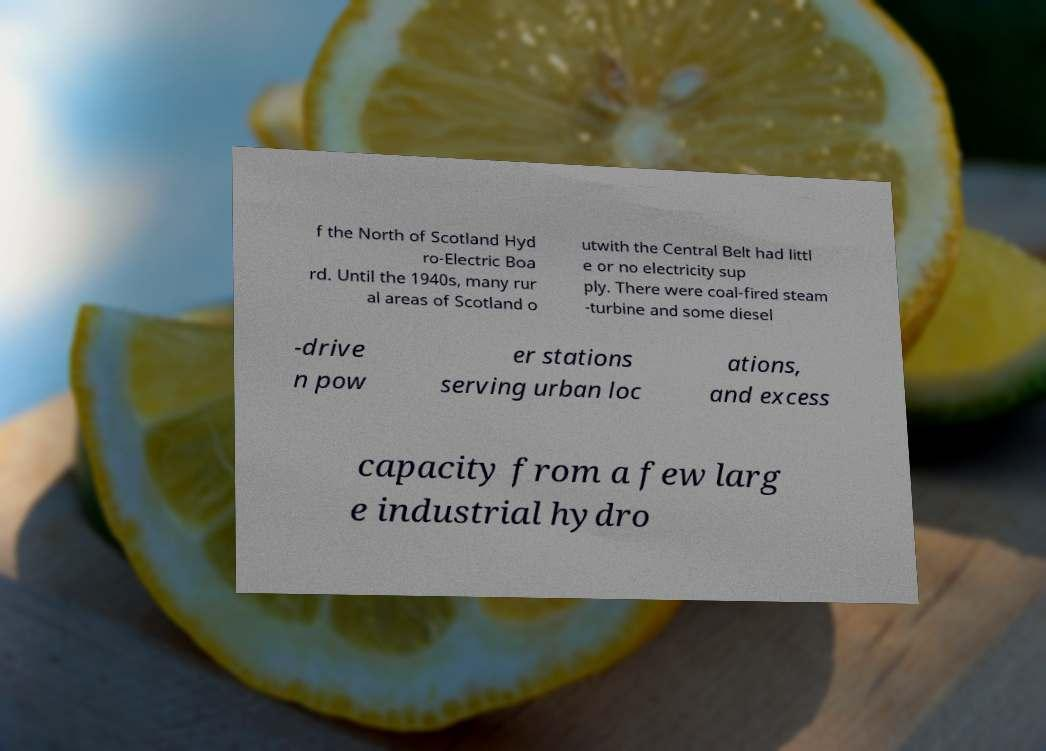I need the written content from this picture converted into text. Can you do that? f the North of Scotland Hyd ro-Electric Boa rd. Until the 1940s, many rur al areas of Scotland o utwith the Central Belt had littl e or no electricity sup ply. There were coal-fired steam -turbine and some diesel -drive n pow er stations serving urban loc ations, and excess capacity from a few larg e industrial hydro 